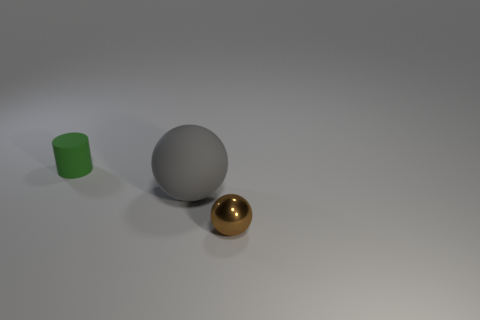Add 1 big gray matte objects. How many objects exist? 4 Add 1 spheres. How many spheres are left? 3 Add 3 small brown things. How many small brown things exist? 4 Subtract 0 cyan cubes. How many objects are left? 3 Subtract all spheres. How many objects are left? 1 Subtract all big cyan shiny cylinders. Subtract all spheres. How many objects are left? 1 